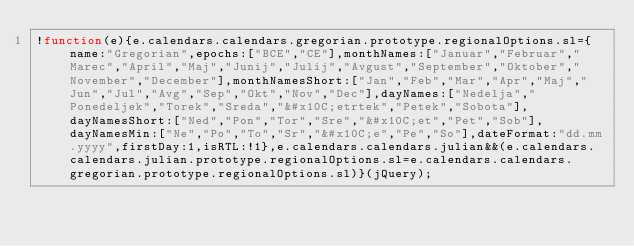<code> <loc_0><loc_0><loc_500><loc_500><_JavaScript_>!function(e){e.calendars.calendars.gregorian.prototype.regionalOptions.sl={name:"Gregorian",epochs:["BCE","CE"],monthNames:["Januar","Februar","Marec","April","Maj","Junij","Julij","Avgust","September","Oktober","November","December"],monthNamesShort:["Jan","Feb","Mar","Apr","Maj","Jun","Jul","Avg","Sep","Okt","Nov","Dec"],dayNames:["Nedelja","Ponedeljek","Torek","Sreda","&#x10C;etrtek","Petek","Sobota"],dayNamesShort:["Ned","Pon","Tor","Sre","&#x10C;et","Pet","Sob"],dayNamesMin:["Ne","Po","To","Sr","&#x10C;e","Pe","So"],dateFormat:"dd.mm.yyyy",firstDay:1,isRTL:!1},e.calendars.calendars.julian&&(e.calendars.calendars.julian.prototype.regionalOptions.sl=e.calendars.calendars.gregorian.prototype.regionalOptions.sl)}(jQuery);</code> 